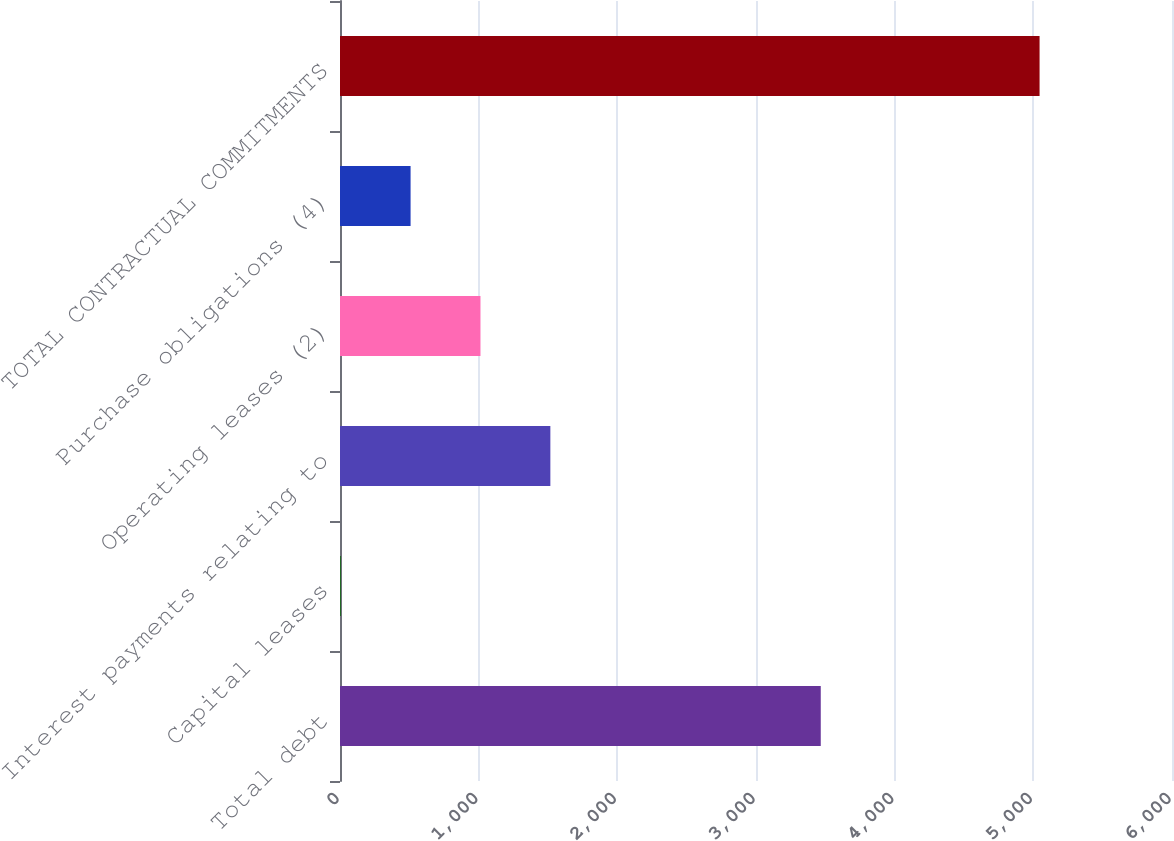Convert chart. <chart><loc_0><loc_0><loc_500><loc_500><bar_chart><fcel>Total debt<fcel>Capital leases<fcel>Interest payments relating to<fcel>Operating leases (2)<fcel>Purchase obligations (4)<fcel>TOTAL CONTRACTUAL COMMITMENTS<nl><fcel>3467<fcel>5<fcel>1517<fcel>1013<fcel>509<fcel>5045<nl></chart> 